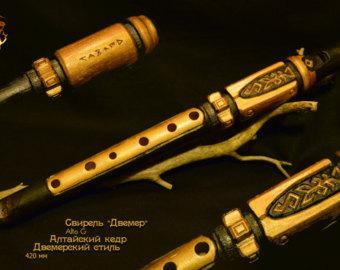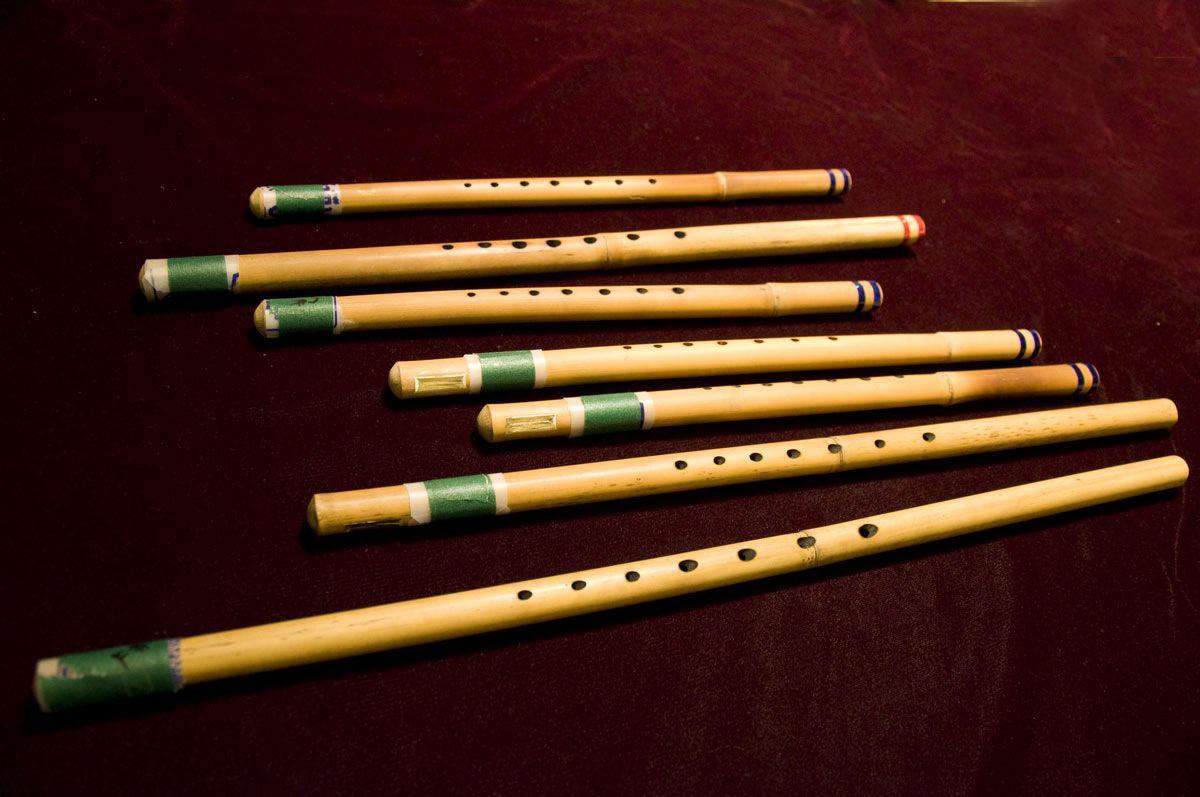The first image is the image on the left, the second image is the image on the right. Examine the images to the left and right. Is the description "One image shows at least four flutes arranged in a row but not perfectly parallel to one another." accurate? Answer yes or no. Yes. The first image is the image on the left, the second image is the image on the right. Examine the images to the left and right. Is the description "There are more than three instruments in at least one of the images." accurate? Answer yes or no. Yes. 